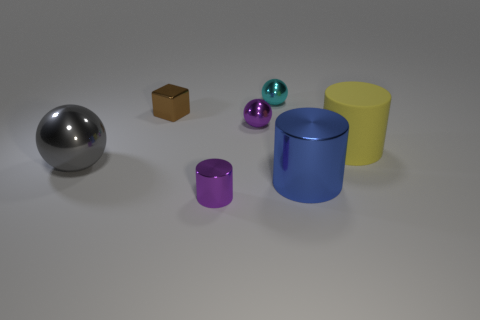Subtract all large gray balls. How many balls are left? 2 Subtract 1 spheres. How many spheres are left? 2 Subtract all cyan balls. How many balls are left? 2 Subtract all red spheres. Subtract all green cubes. How many spheres are left? 3 Subtract all blocks. How many objects are left? 6 Add 1 metal balls. How many objects exist? 8 Add 1 small purple spheres. How many small purple spheres are left? 2 Add 5 large blue things. How many large blue things exist? 6 Subtract 0 brown cylinders. How many objects are left? 7 Subtract all large cyan rubber cylinders. Subtract all tiny cyan metallic objects. How many objects are left? 6 